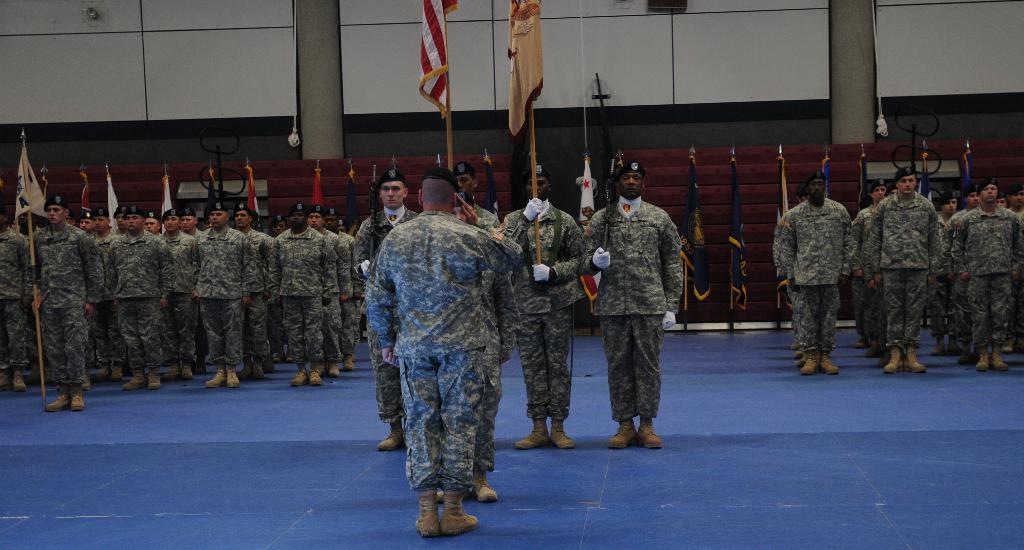How would you summarize this image in a sentence or two? In the image there are many people with uniforms is standing with hats on their heads. And also there are wearing shoes and holding flags in their hands. Behind them there are poles with flags. And also there are pillars and there is a wall. 